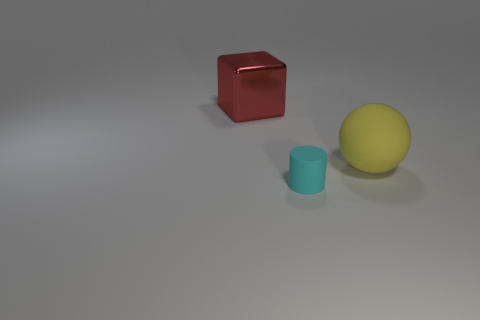Add 1 yellow rubber objects. How many objects exist? 4 Subtract all cylinders. How many objects are left? 2 Subtract 0 yellow cubes. How many objects are left? 3 Subtract all big brown matte blocks. Subtract all small cyan cylinders. How many objects are left? 2 Add 3 big red metallic objects. How many big red metallic objects are left? 4 Add 1 small brown metallic cylinders. How many small brown metallic cylinders exist? 1 